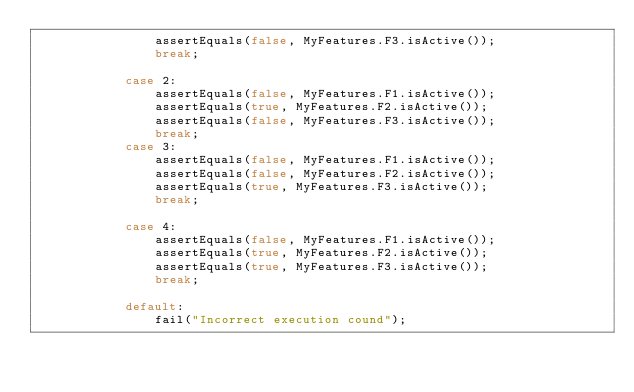<code> <loc_0><loc_0><loc_500><loc_500><_Java_>                assertEquals(false, MyFeatures.F3.isActive());
                break;

            case 2:
                assertEquals(false, MyFeatures.F1.isActive());
                assertEquals(true, MyFeatures.F2.isActive());
                assertEquals(false, MyFeatures.F3.isActive());
                break;
            case 3:
                assertEquals(false, MyFeatures.F1.isActive());
                assertEquals(false, MyFeatures.F2.isActive());
                assertEquals(true, MyFeatures.F3.isActive());
                break;

            case 4:
                assertEquals(false, MyFeatures.F1.isActive());
                assertEquals(true, MyFeatures.F2.isActive());
                assertEquals(true, MyFeatures.F3.isActive());
                break;

            default:
                fail("Incorrect execution cound");
</code> 